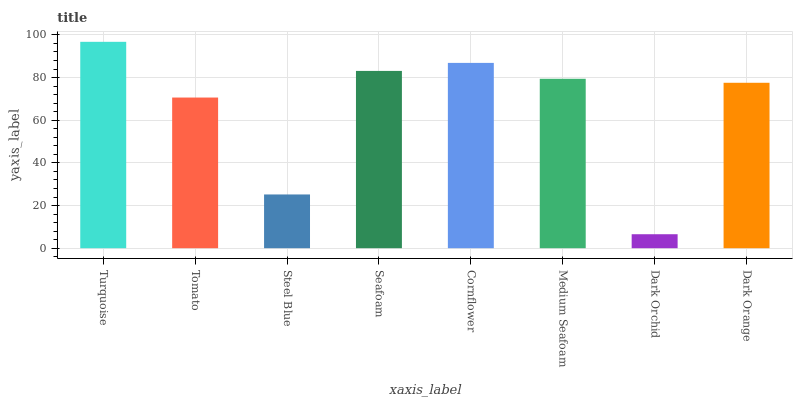Is Dark Orchid the minimum?
Answer yes or no. Yes. Is Turquoise the maximum?
Answer yes or no. Yes. Is Tomato the minimum?
Answer yes or no. No. Is Tomato the maximum?
Answer yes or no. No. Is Turquoise greater than Tomato?
Answer yes or no. Yes. Is Tomato less than Turquoise?
Answer yes or no. Yes. Is Tomato greater than Turquoise?
Answer yes or no. No. Is Turquoise less than Tomato?
Answer yes or no. No. Is Medium Seafoam the high median?
Answer yes or no. Yes. Is Dark Orange the low median?
Answer yes or no. Yes. Is Seafoam the high median?
Answer yes or no. No. Is Turquoise the low median?
Answer yes or no. No. 